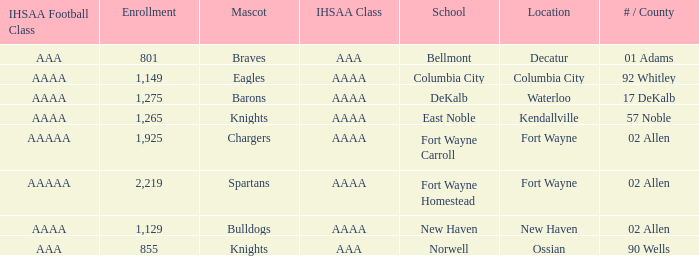What's the IHSAA Football Class in Decatur with an AAA IHSAA class? AAA. 